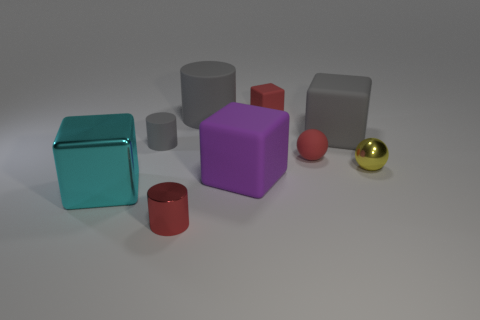Subtract all cylinders. How many objects are left? 6 Add 3 small metallic balls. How many small metallic balls are left? 4 Add 1 tiny rubber cylinders. How many tiny rubber cylinders exist? 2 Subtract 0 green balls. How many objects are left? 9 Subtract all tiny cylinders. Subtract all shiny balls. How many objects are left? 6 